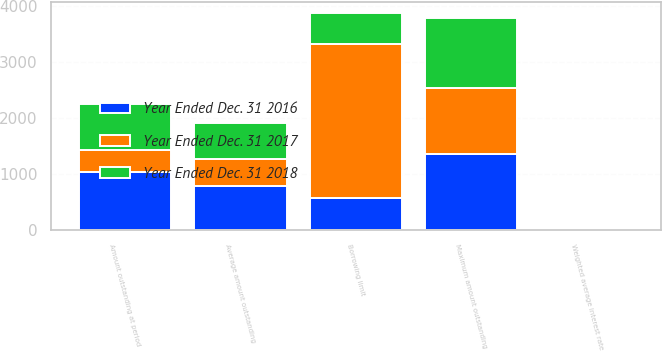Convert chart to OTSL. <chart><loc_0><loc_0><loc_500><loc_500><stacked_bar_chart><ecel><fcel>Borrowing limit<fcel>Amount outstanding at period<fcel>Average amount outstanding<fcel>Maximum amount outstanding<fcel>Weighted average interest rate<nl><fcel>Year Ended Dec. 31 2016<fcel>564.5<fcel>1038<fcel>788<fcel>1349<fcel>2.97<nl><fcel>Year Ended Dec. 31 2018<fcel>564.5<fcel>814<fcel>644<fcel>1247<fcel>1.9<nl><fcel>Year Ended Dec. 31 2017<fcel>2750<fcel>392<fcel>485<fcel>1183<fcel>0.95<nl></chart> 